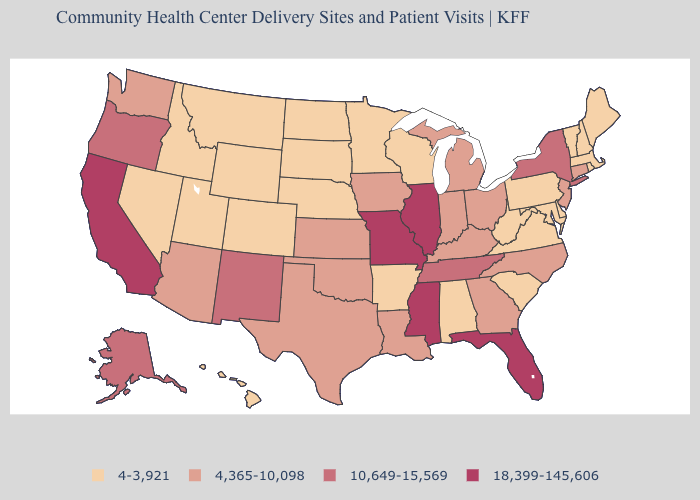Does the first symbol in the legend represent the smallest category?
Write a very short answer. Yes. What is the lowest value in states that border Indiana?
Be succinct. 4,365-10,098. Does California have a higher value than Kentucky?
Write a very short answer. Yes. Among the states that border Illinois , which have the lowest value?
Keep it brief. Wisconsin. How many symbols are there in the legend?
Concise answer only. 4. What is the value of West Virginia?
Answer briefly. 4-3,921. What is the value of Vermont?
Keep it brief. 4-3,921. What is the value of Alabama?
Concise answer only. 4-3,921. What is the value of Vermont?
Give a very brief answer. 4-3,921. Name the states that have a value in the range 4-3,921?
Concise answer only. Alabama, Arkansas, Colorado, Delaware, Hawaii, Idaho, Maine, Maryland, Massachusetts, Minnesota, Montana, Nebraska, Nevada, New Hampshire, North Dakota, Pennsylvania, Rhode Island, South Carolina, South Dakota, Utah, Vermont, Virginia, West Virginia, Wisconsin, Wyoming. Name the states that have a value in the range 10,649-15,569?
Write a very short answer. Alaska, New Mexico, New York, Oregon, Tennessee. Name the states that have a value in the range 4,365-10,098?
Quick response, please. Arizona, Connecticut, Georgia, Indiana, Iowa, Kansas, Kentucky, Louisiana, Michigan, New Jersey, North Carolina, Ohio, Oklahoma, Texas, Washington. What is the lowest value in the USA?
Answer briefly. 4-3,921. What is the lowest value in states that border Louisiana?
Be succinct. 4-3,921. What is the highest value in the USA?
Quick response, please. 18,399-145,606. 